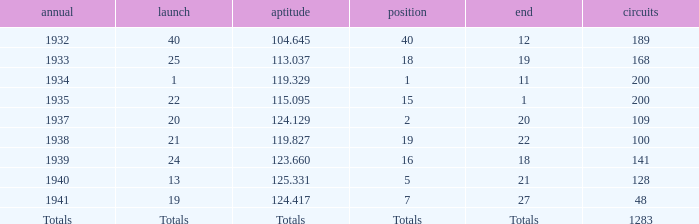What was the rank with the qual of 115.095? 15.0. 